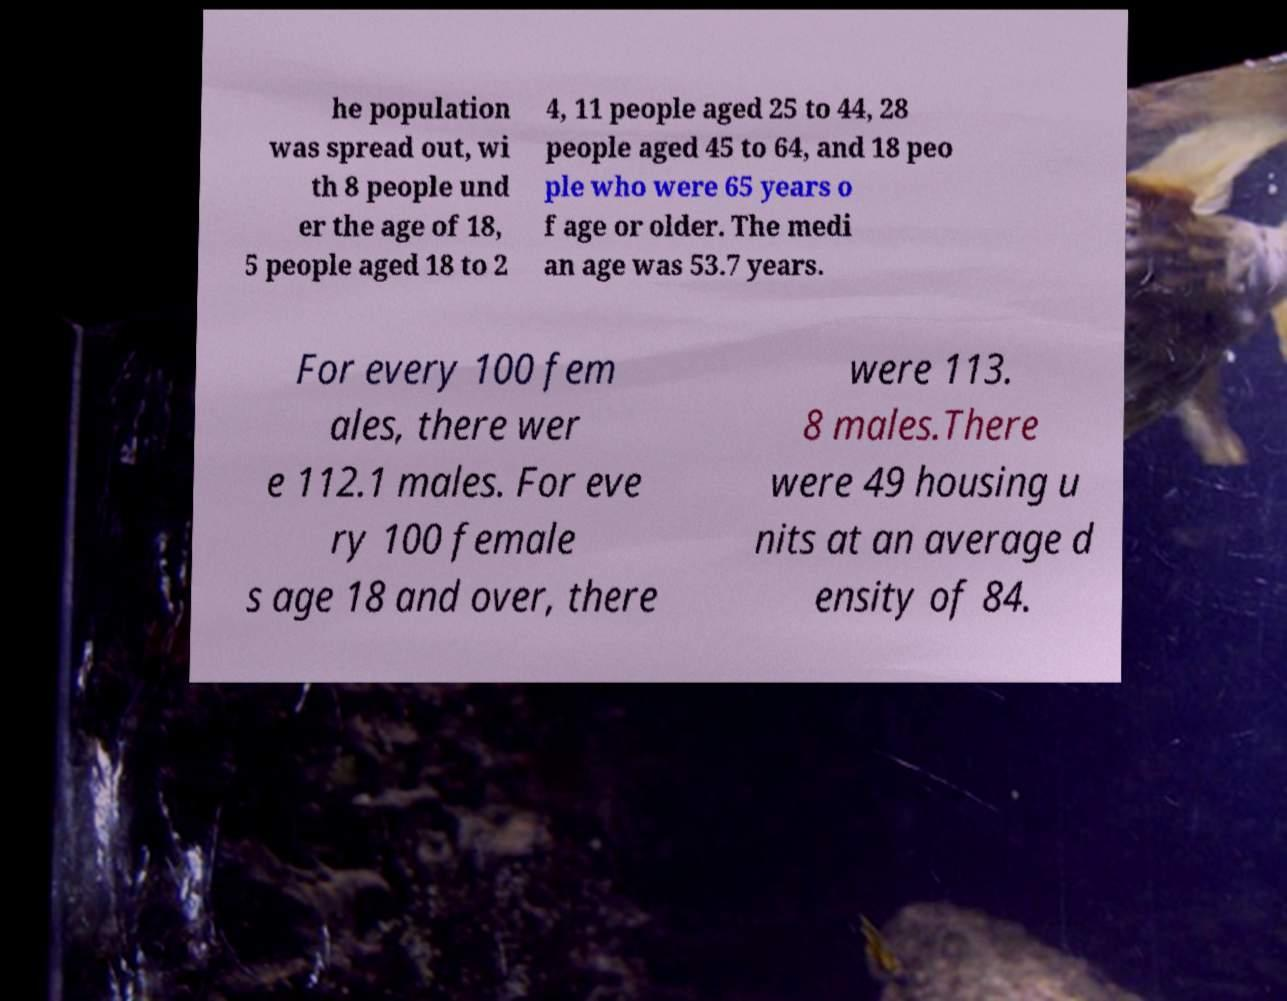Could you extract and type out the text from this image? he population was spread out, wi th 8 people und er the age of 18, 5 people aged 18 to 2 4, 11 people aged 25 to 44, 28 people aged 45 to 64, and 18 peo ple who were 65 years o f age or older. The medi an age was 53.7 years. For every 100 fem ales, there wer e 112.1 males. For eve ry 100 female s age 18 and over, there were 113. 8 males.There were 49 housing u nits at an average d ensity of 84. 